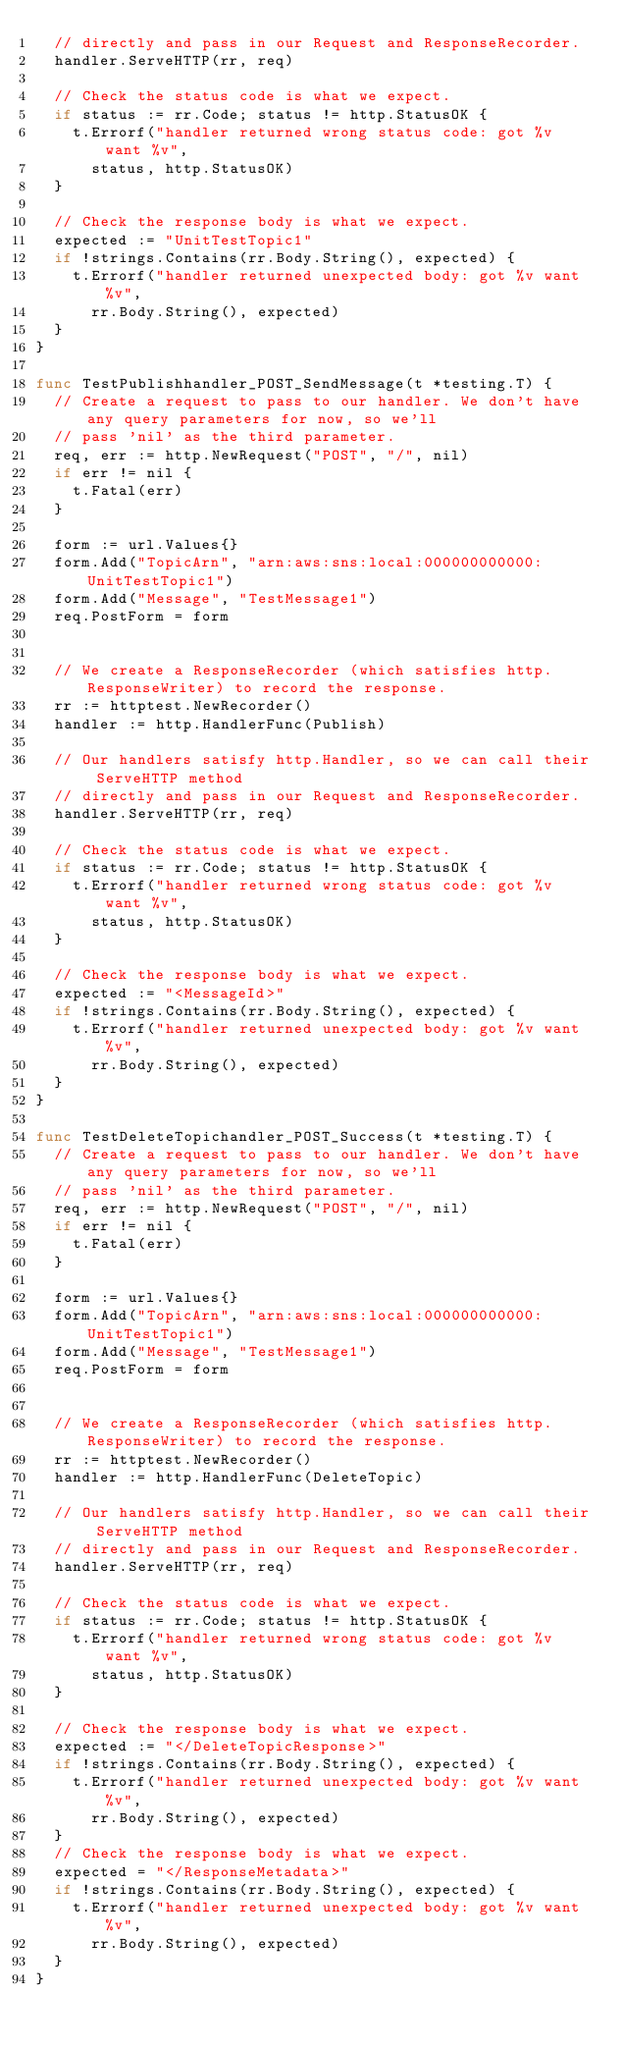<code> <loc_0><loc_0><loc_500><loc_500><_Go_>	// directly and pass in our Request and ResponseRecorder.
	handler.ServeHTTP(rr, req)

	// Check the status code is what we expect.
	if status := rr.Code; status != http.StatusOK {
		t.Errorf("handler returned wrong status code: got %v want %v",
			status, http.StatusOK)
	}

	// Check the response body is what we expect.
	expected := "UnitTestTopic1"
	if !strings.Contains(rr.Body.String(), expected) {
		t.Errorf("handler returned unexpected body: got %v want %v",
			rr.Body.String(), expected)
	}
}

func TestPublishhandler_POST_SendMessage(t *testing.T) {
	// Create a request to pass to our handler. We don't have any query parameters for now, so we'll
	// pass 'nil' as the third parameter.
	req, err := http.NewRequest("POST", "/", nil)
	if err != nil {
		t.Fatal(err)
	}

	form := url.Values{}
	form.Add("TopicArn", "arn:aws:sns:local:000000000000:UnitTestTopic1")
	form.Add("Message", "TestMessage1")
	req.PostForm = form


	// We create a ResponseRecorder (which satisfies http.ResponseWriter) to record the response.
	rr := httptest.NewRecorder()
	handler := http.HandlerFunc(Publish)

	// Our handlers satisfy http.Handler, so we can call their ServeHTTP method
	// directly and pass in our Request and ResponseRecorder.
	handler.ServeHTTP(rr, req)

	// Check the status code is what we expect.
	if status := rr.Code; status != http.StatusOK {
		t.Errorf("handler returned wrong status code: got %v want %v",
			status, http.StatusOK)
	}

	// Check the response body is what we expect.
	expected := "<MessageId>"
	if !strings.Contains(rr.Body.String(), expected) {
		t.Errorf("handler returned unexpected body: got %v want %v",
			rr.Body.String(), expected)
	}
}

func TestDeleteTopichandler_POST_Success(t *testing.T) {
	// Create a request to pass to our handler. We don't have any query parameters for now, so we'll
	// pass 'nil' as the third parameter.
	req, err := http.NewRequest("POST", "/", nil)
	if err != nil {
		t.Fatal(err)
	}

	form := url.Values{}
	form.Add("TopicArn", "arn:aws:sns:local:000000000000:UnitTestTopic1")
	form.Add("Message", "TestMessage1")
	req.PostForm = form


	// We create a ResponseRecorder (which satisfies http.ResponseWriter) to record the response.
	rr := httptest.NewRecorder()
	handler := http.HandlerFunc(DeleteTopic)

	// Our handlers satisfy http.Handler, so we can call their ServeHTTP method
	// directly and pass in our Request and ResponseRecorder.
	handler.ServeHTTP(rr, req)

	// Check the status code is what we expect.
	if status := rr.Code; status != http.StatusOK {
		t.Errorf("handler returned wrong status code: got %v want %v",
			status, http.StatusOK)
	}

	// Check the response body is what we expect.
	expected := "</DeleteTopicResponse>"
	if !strings.Contains(rr.Body.String(), expected) {
		t.Errorf("handler returned unexpected body: got %v want %v",
			rr.Body.String(), expected)
	}
	// Check the response body is what we expect.
	expected = "</ResponseMetadata>"
	if !strings.Contains(rr.Body.String(), expected) {
		t.Errorf("handler returned unexpected body: got %v want %v",
			rr.Body.String(), expected)
	}
}
</code> 